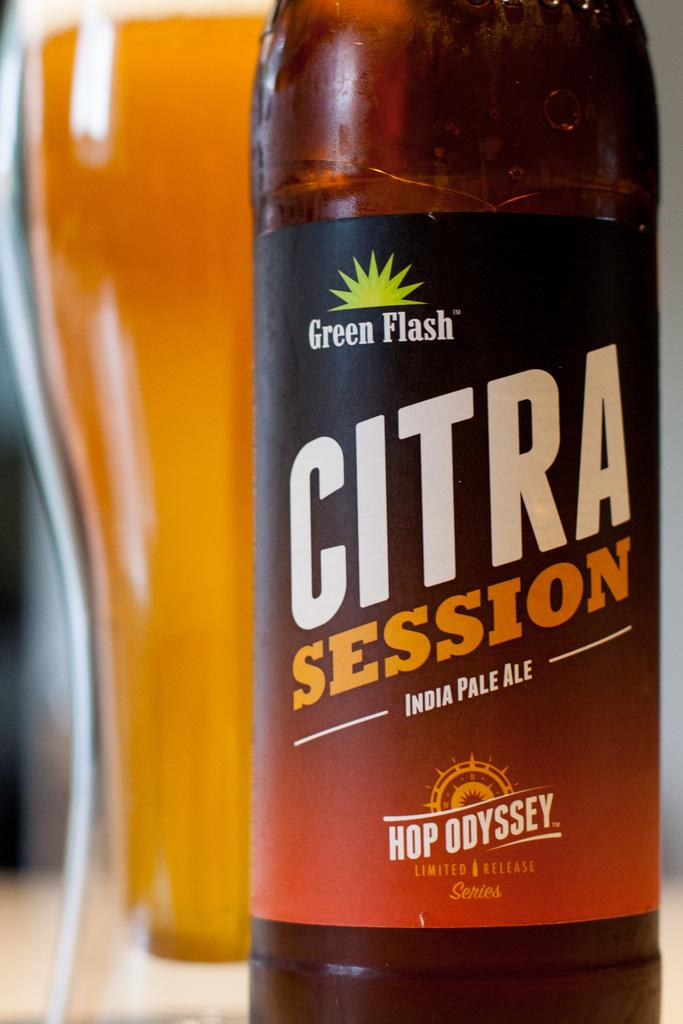<image>
Render a clear and concise summary of the photo. A bottle of Citra Session India Pale Ale is displayed in front of a pilsner glass of beer. 